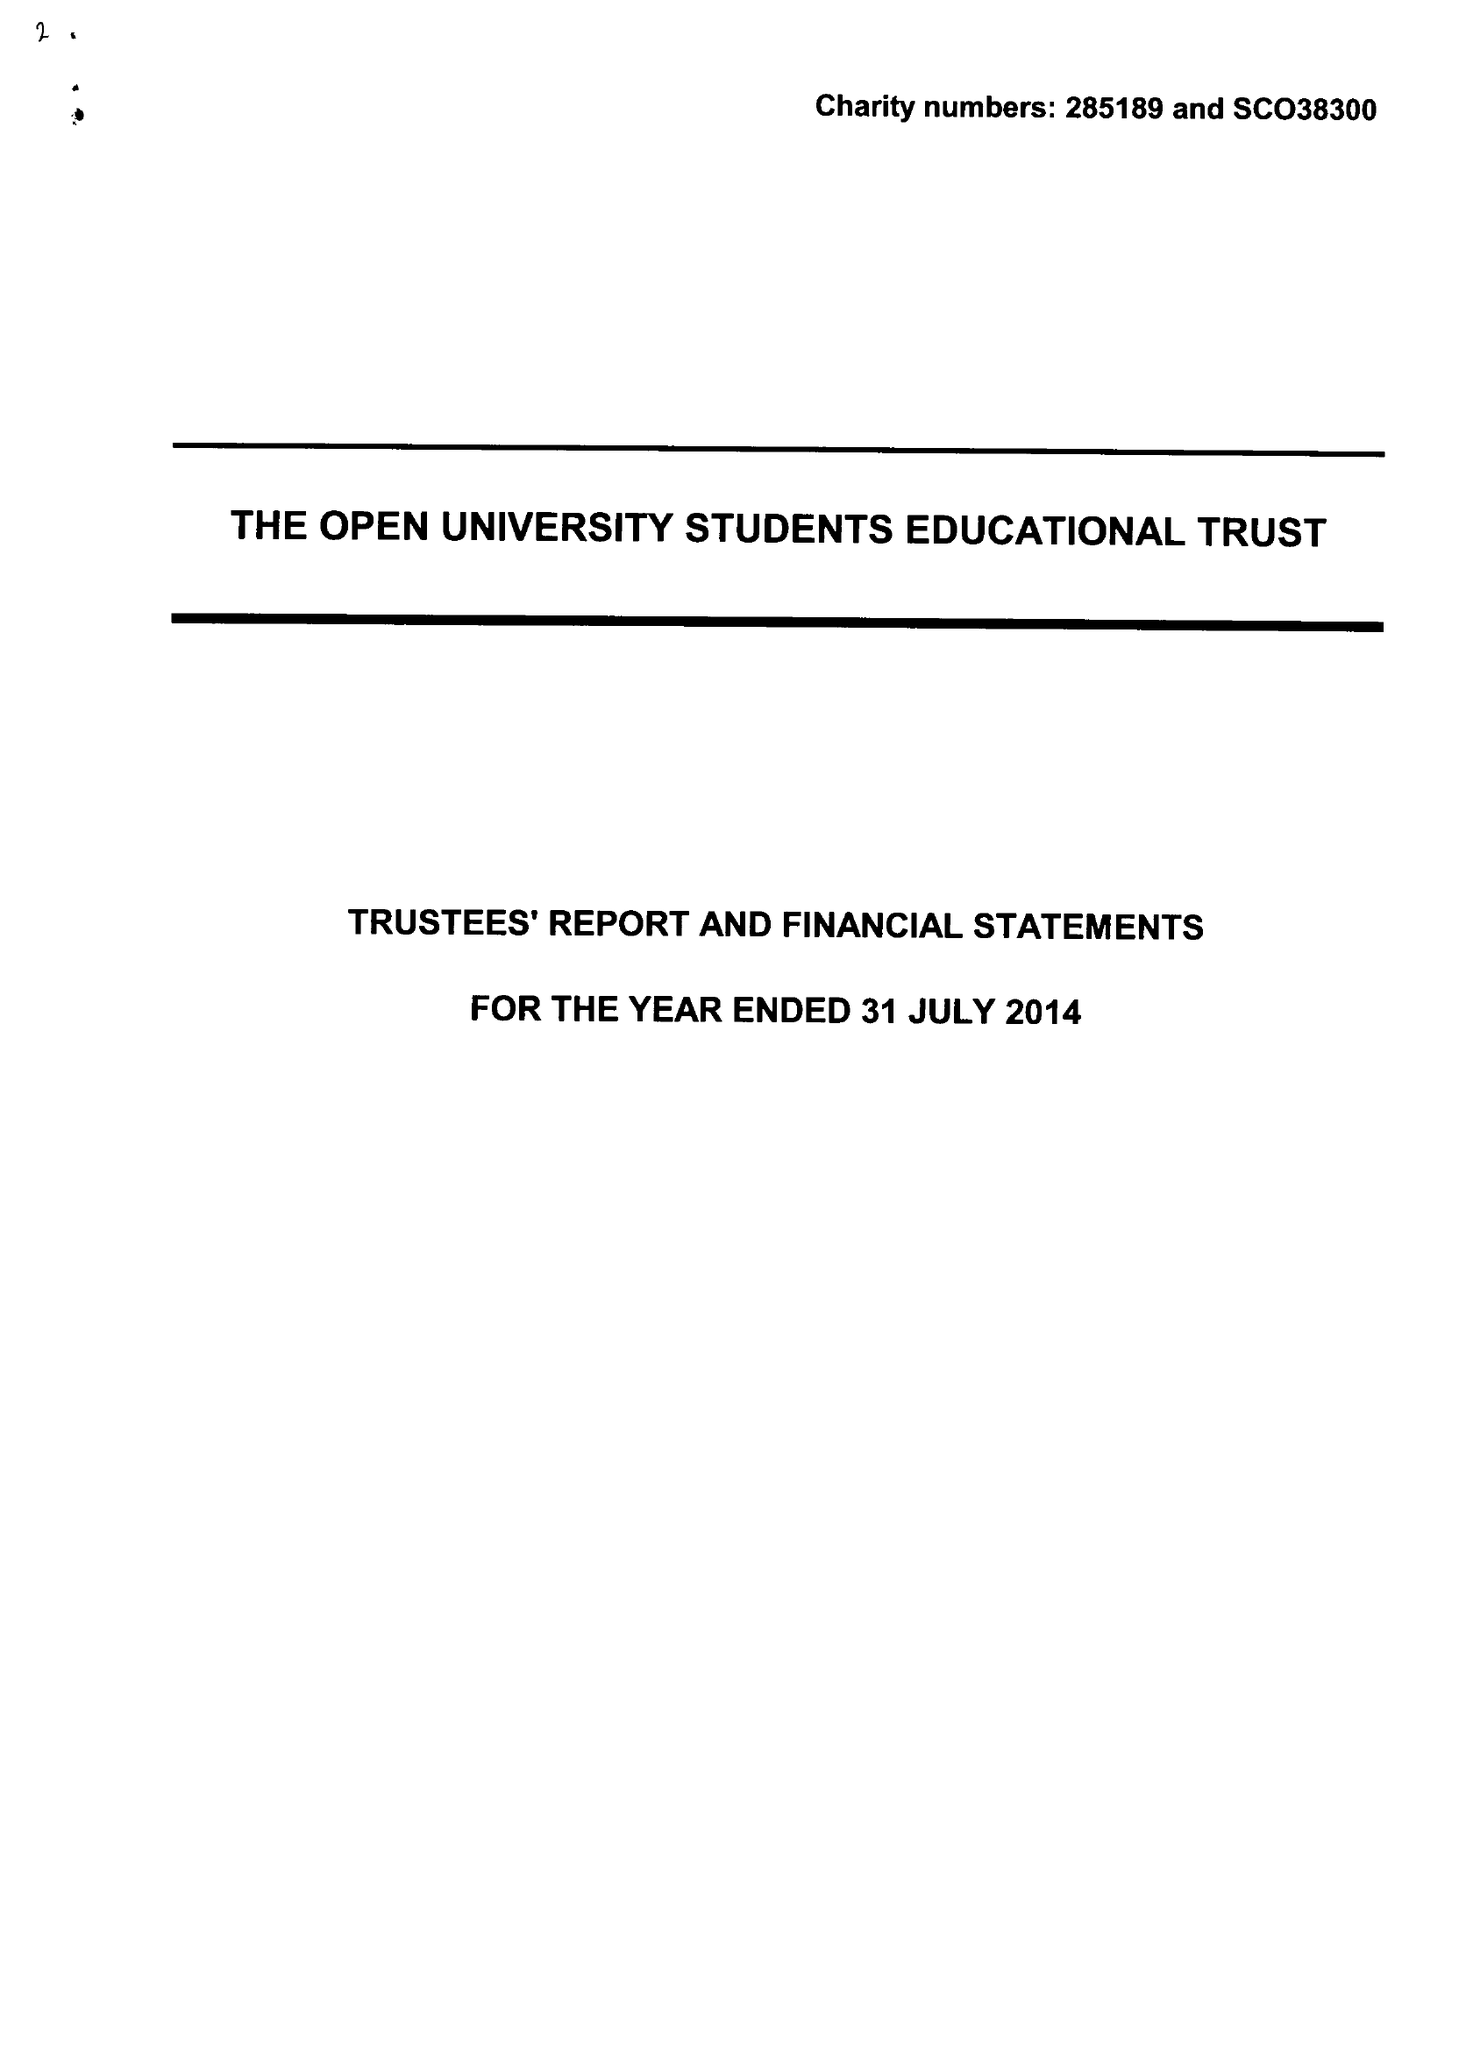What is the value for the charity_number?
Answer the question using a single word or phrase. 285189 